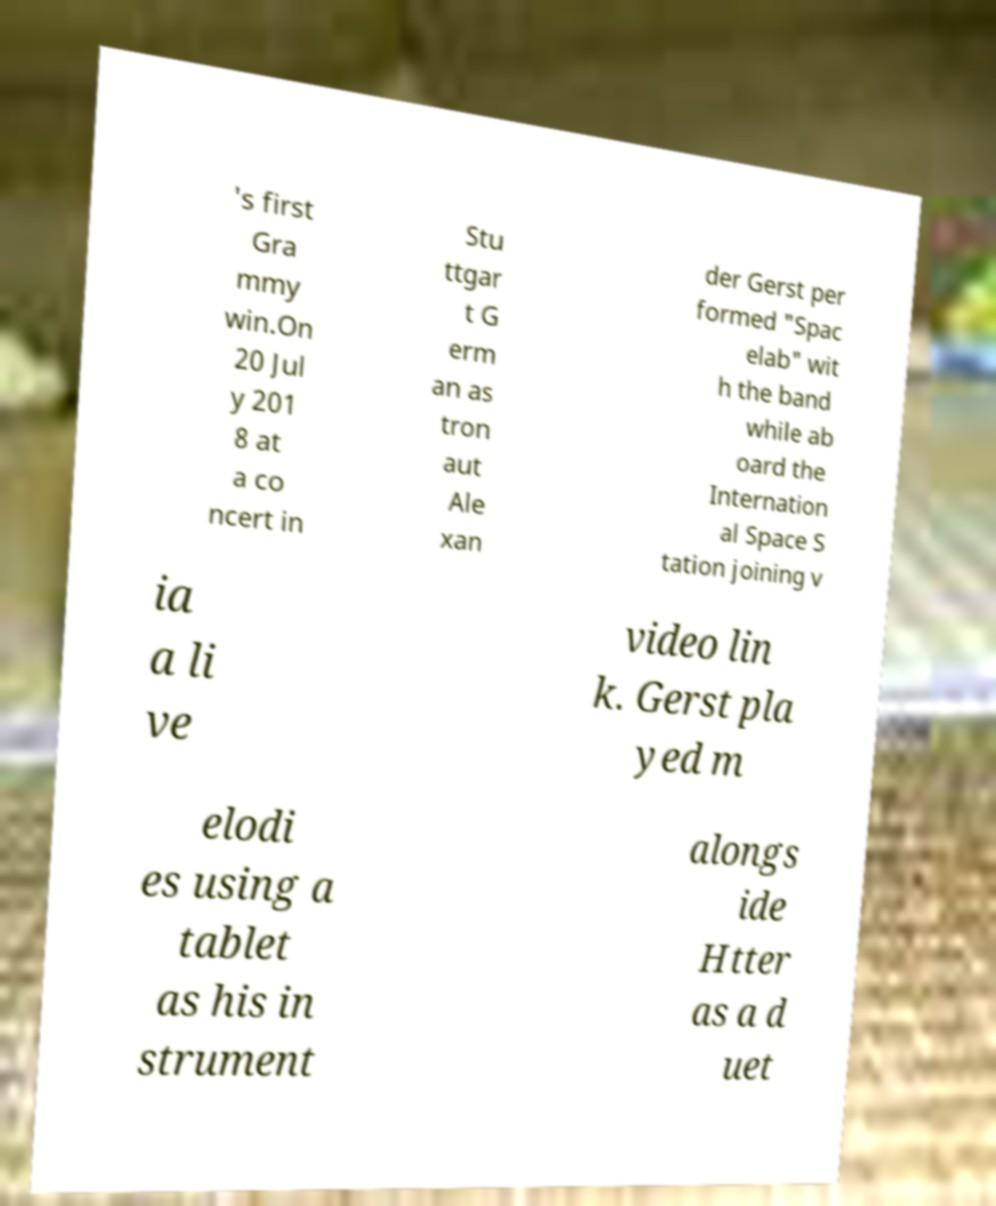There's text embedded in this image that I need extracted. Can you transcribe it verbatim? 's first Gra mmy win.On 20 Jul y 201 8 at a co ncert in Stu ttgar t G erm an as tron aut Ale xan der Gerst per formed "Spac elab" wit h the band while ab oard the Internation al Space S tation joining v ia a li ve video lin k. Gerst pla yed m elodi es using a tablet as his in strument alongs ide Htter as a d uet 